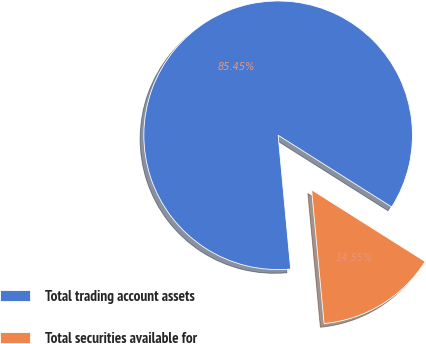<chart> <loc_0><loc_0><loc_500><loc_500><pie_chart><fcel>Total trading account assets<fcel>Total securities available for<nl><fcel>85.45%<fcel>14.55%<nl></chart> 